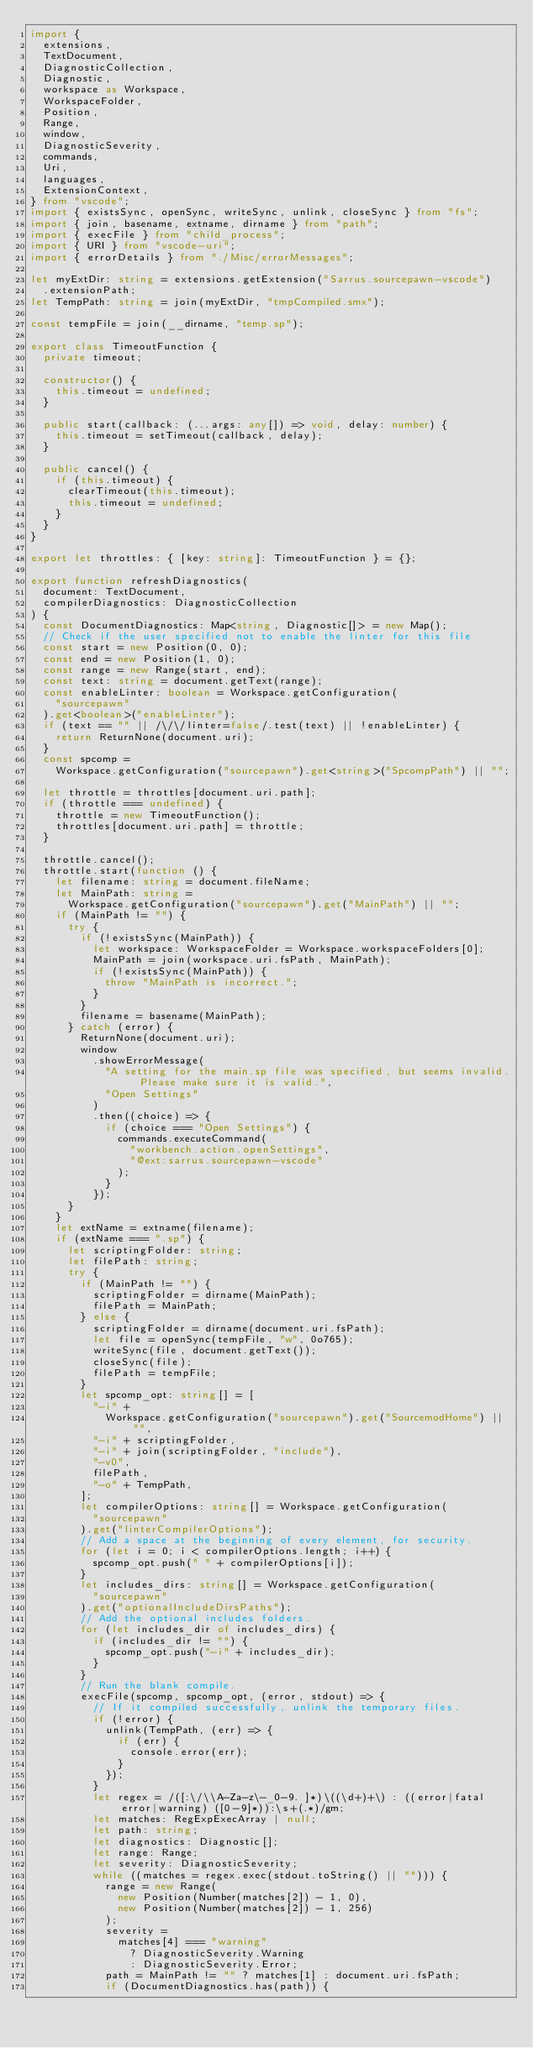Convert code to text. <code><loc_0><loc_0><loc_500><loc_500><_TypeScript_>import {
  extensions,
  TextDocument,
  DiagnosticCollection,
  Diagnostic,
  workspace as Workspace,
  WorkspaceFolder,
  Position,
  Range,
  window,
  DiagnosticSeverity,
  commands,
  Uri,
  languages,
  ExtensionContext,
} from "vscode";
import { existsSync, openSync, writeSync, unlink, closeSync } from "fs";
import { join, basename, extname, dirname } from "path";
import { execFile } from "child_process";
import { URI } from "vscode-uri";
import { errorDetails } from "./Misc/errorMessages";

let myExtDir: string = extensions.getExtension("Sarrus.sourcepawn-vscode")
  .extensionPath;
let TempPath: string = join(myExtDir, "tmpCompiled.smx");

const tempFile = join(__dirname, "temp.sp");

export class TimeoutFunction {
  private timeout;

  constructor() {
    this.timeout = undefined;
  }

  public start(callback: (...args: any[]) => void, delay: number) {
    this.timeout = setTimeout(callback, delay);
  }

  public cancel() {
    if (this.timeout) {
      clearTimeout(this.timeout);
      this.timeout = undefined;
    }
  }
}

export let throttles: { [key: string]: TimeoutFunction } = {};

export function refreshDiagnostics(
  document: TextDocument,
  compilerDiagnostics: DiagnosticCollection
) {
  const DocumentDiagnostics: Map<string, Diagnostic[]> = new Map();
  // Check if the user specified not to enable the linter for this file
  const start = new Position(0, 0);
  const end = new Position(1, 0);
  const range = new Range(start, end);
  const text: string = document.getText(range);
  const enableLinter: boolean = Workspace.getConfiguration(
    "sourcepawn"
  ).get<boolean>("enableLinter");
  if (text == "" || /\/\/linter=false/.test(text) || !enableLinter) {
    return ReturnNone(document.uri);
  }
  const spcomp =
    Workspace.getConfiguration("sourcepawn").get<string>("SpcompPath") || "";

  let throttle = throttles[document.uri.path];
  if (throttle === undefined) {
    throttle = new TimeoutFunction();
    throttles[document.uri.path] = throttle;
  }

  throttle.cancel();
  throttle.start(function () {
    let filename: string = document.fileName;
    let MainPath: string =
      Workspace.getConfiguration("sourcepawn").get("MainPath") || "";
    if (MainPath != "") {
      try {
        if (!existsSync(MainPath)) {
          let workspace: WorkspaceFolder = Workspace.workspaceFolders[0];
          MainPath = join(workspace.uri.fsPath, MainPath);
          if (!existsSync(MainPath)) {
            throw "MainPath is incorrect.";
          }
        }
        filename = basename(MainPath);
      } catch (error) {
        ReturnNone(document.uri);
        window
          .showErrorMessage(
            "A setting for the main.sp file was specified, but seems invalid. Please make sure it is valid.",
            "Open Settings"
          )
          .then((choice) => {
            if (choice === "Open Settings") {
              commands.executeCommand(
                "workbench.action.openSettings",
                "@ext:sarrus.sourcepawn-vscode"
              );
            }
          });
      }
    }
    let extName = extname(filename);
    if (extName === ".sp") {
      let scriptingFolder: string;
      let filePath: string;
      try {
        if (MainPath != "") {
          scriptingFolder = dirname(MainPath);
          filePath = MainPath;
        } else {
          scriptingFolder = dirname(document.uri.fsPath);
          let file = openSync(tempFile, "w", 0o765);
          writeSync(file, document.getText());
          closeSync(file);
          filePath = tempFile;
        }
        let spcomp_opt: string[] = [
          "-i" +
            Workspace.getConfiguration("sourcepawn").get("SourcemodHome") || "",
          "-i" + scriptingFolder,
          "-i" + join(scriptingFolder, "include"),
          "-v0",
          filePath,
          "-o" + TempPath,
        ];
        let compilerOptions: string[] = Workspace.getConfiguration(
          "sourcepawn"
        ).get("linterCompilerOptions");
        // Add a space at the beginning of every element, for security.
        for (let i = 0; i < compilerOptions.length; i++) {
          spcomp_opt.push(" " + compilerOptions[i]);
        }
        let includes_dirs: string[] = Workspace.getConfiguration(
          "sourcepawn"
        ).get("optionalIncludeDirsPaths");
        // Add the optional includes folders.
        for (let includes_dir of includes_dirs) {
          if (includes_dir != "") {
            spcomp_opt.push("-i" + includes_dir);
          }
        }
        // Run the blank compile.
        execFile(spcomp, spcomp_opt, (error, stdout) => {
          // If it compiled successfully, unlink the temporary files.
          if (!error) {
            unlink(TempPath, (err) => {
              if (err) {
                console.error(err);
              }
            });
          }
          let regex = /([:\/\\A-Za-z\-_0-9. ]*)\((\d+)+\) : ((error|fatal error|warning) ([0-9]*)):\s+(.*)/gm;
          let matches: RegExpExecArray | null;
          let path: string;
          let diagnostics: Diagnostic[];
          let range: Range;
          let severity: DiagnosticSeverity;
          while ((matches = regex.exec(stdout.toString() || ""))) {
            range = new Range(
              new Position(Number(matches[2]) - 1, 0),
              new Position(Number(matches[2]) - 1, 256)
            );
            severity =
              matches[4] === "warning"
                ? DiagnosticSeverity.Warning
                : DiagnosticSeverity.Error;
            path = MainPath != "" ? matches[1] : document.uri.fsPath;
            if (DocumentDiagnostics.has(path)) {</code> 